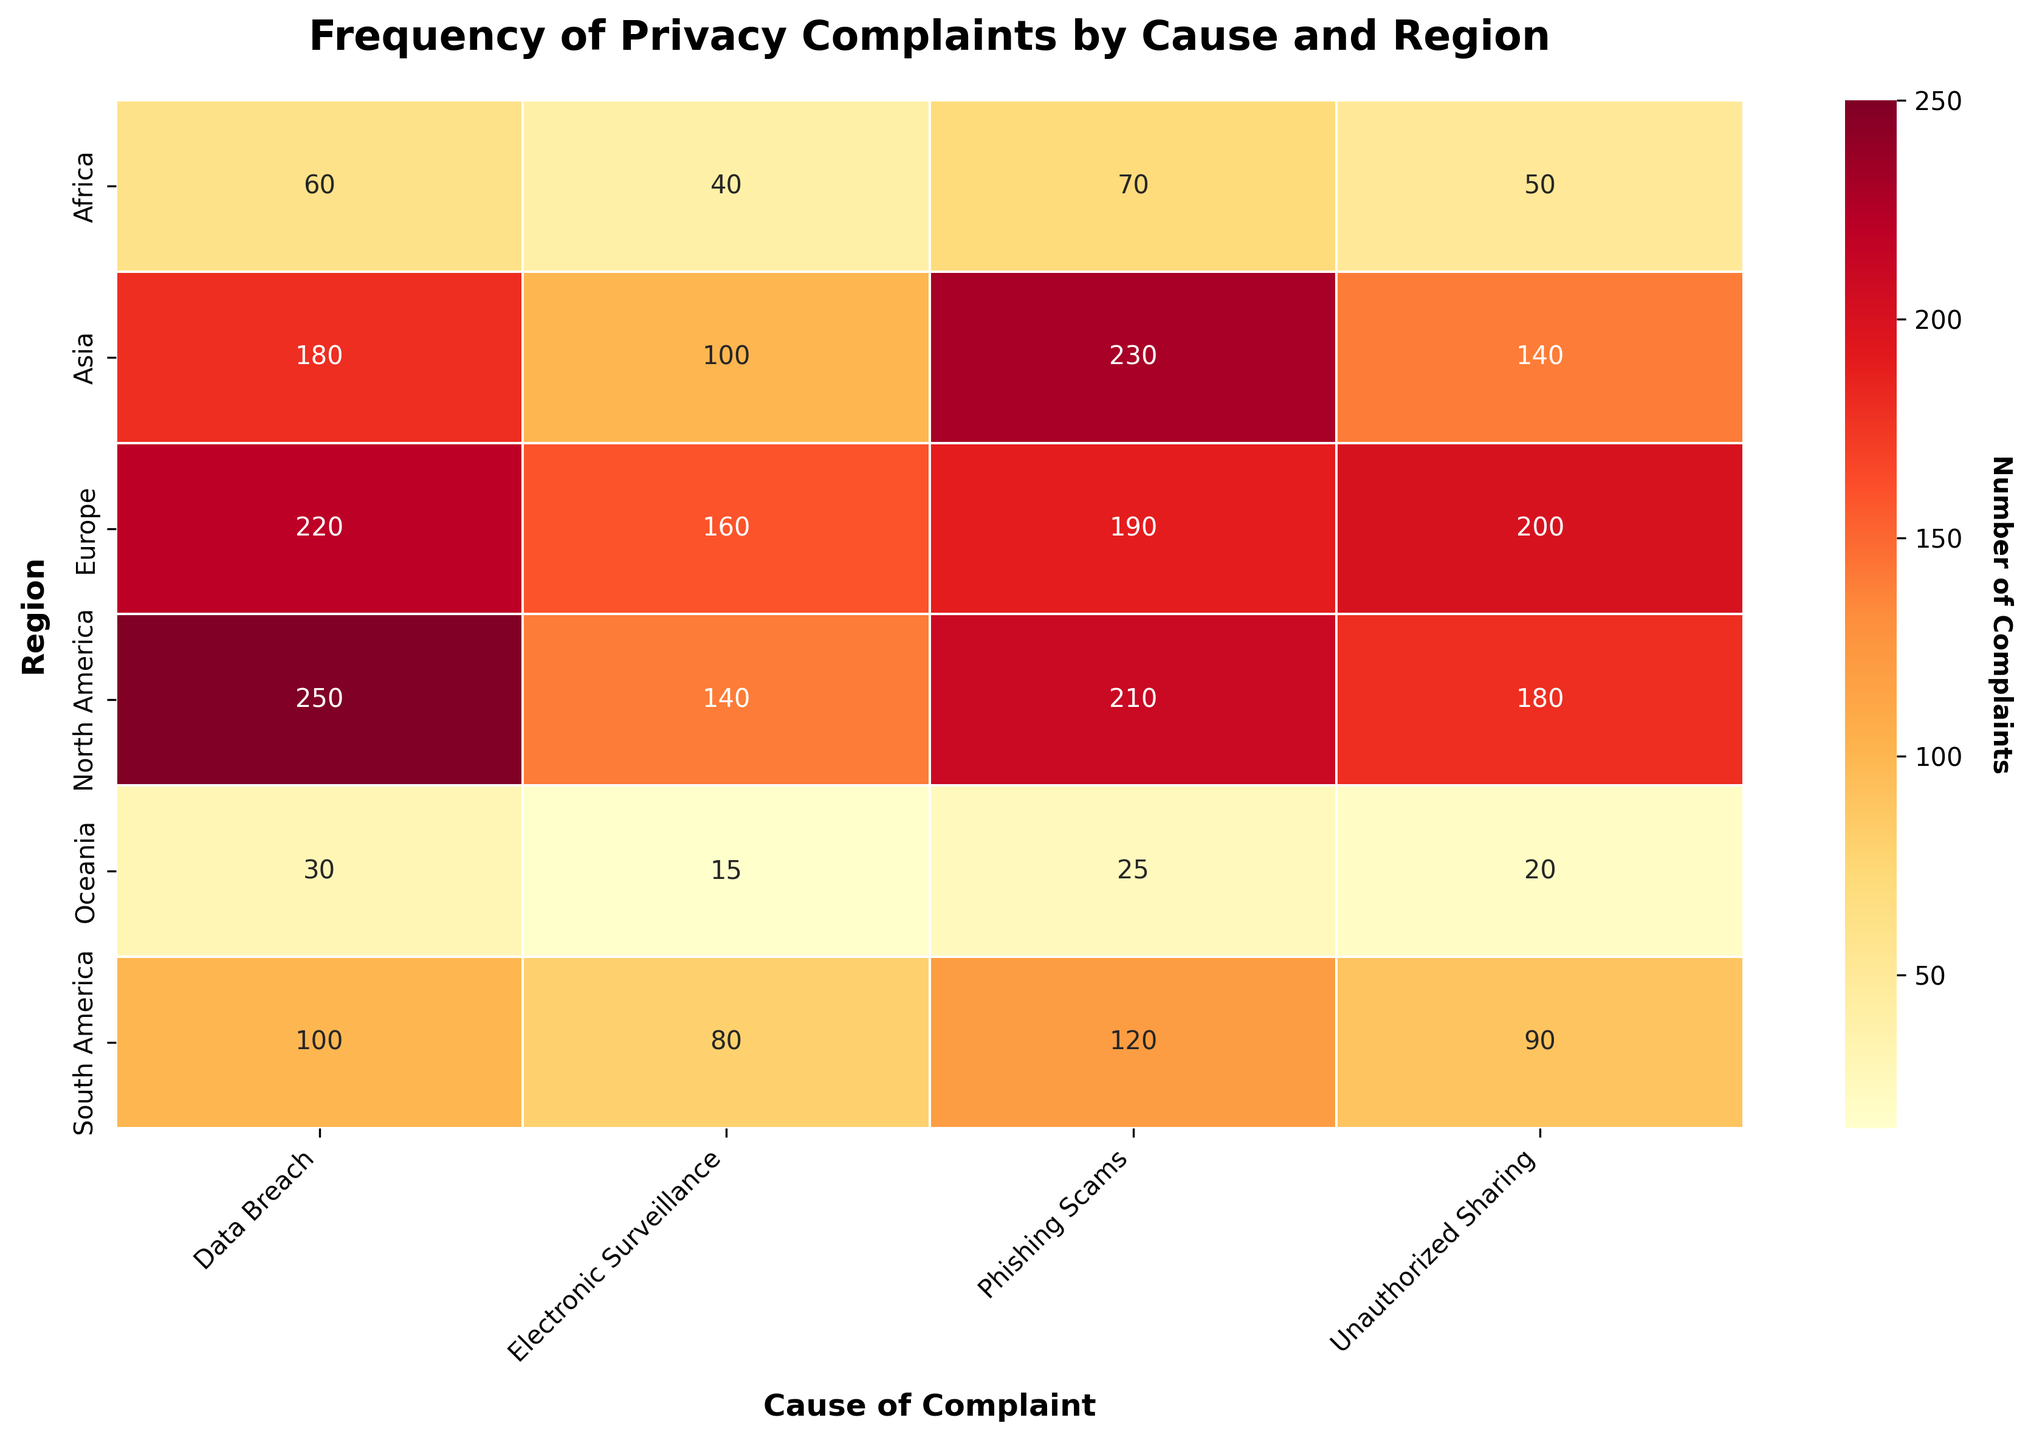Can you tell me the title of the plot? The title is usually placed at the top of the plot, and in this figure, it reads 'Frequency of Privacy Complaints by Cause and Region'.
Answer: Frequency of Privacy Complaints by Cause and Region Which region has the highest number of complaints for Data Breach? Looking at the Data Breach column, the region with the highest number of complaints is North America with a value of 250.
Answer: North America How many total complaints are reported in Europe for Unauthorized Sharing and Phishing Scams combined? For Europe, add the number of complaints for Unauthorized Sharing (200) and Phishing Scams (190): 200 + 190 = 390.
Answer: 390 Which cause of complaints has the least number of incidents in Oceania? Referring to the Oceania row, Electronic Surveillance has the least number of incidents with a value of 15.
Answer: Electronic Surveillance Compare the number of Phishing Scams complaints between North America and Europe. Which region has more complaints and by how much? North America has 210 complaints and Europe has 190 complaints for Phishing Scams. North America has 210 - 190 = 20 more complaints than Europe.
Answer: North America by 20 What is the average number of complaints for Data Breach reported across all regions? Sum up the complaints for Data Breach across all regions: 250 + 220 + 180 + 100 + 60 + 30 = 840. There are 6 regions, so the average is 840/6 = 140.
Answer: 140 In which region is the overall frequency of privacy complaints the lowest? Sum the complaints in each region. Oceania has the lowest overall with 30 + 20 + 25 + 15 = 90.
Answer: Oceania Which cause of complaint has the highest number of reported incidents in Asia? In the Asia row, Phishing Scams has the highest number of reported incidents with a value of 230.
Answer: Phishing Scams Is the overall number of complaints higher in North America or Asia? Sum the complaints in North America (250 + 180 + 210 + 140 = 780) and in Asia (180 + 140 + 230 + 100 = 650). North America has more complaints overall.
Answer: North America 